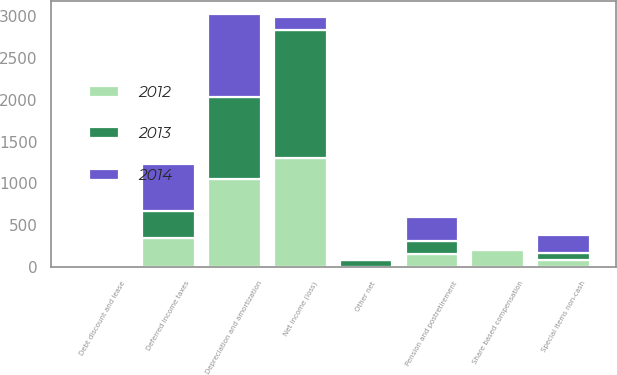Convert chart to OTSL. <chart><loc_0><loc_0><loc_500><loc_500><stacked_bar_chart><ecel><fcel>Net income (loss)<fcel>Depreciation and amortization<fcel>Debt discount and lease<fcel>Special items non-cash<fcel>Pension and postretirement<fcel>Deferred income taxes<fcel>Share based compensation<fcel>Other net<nl><fcel>2012<fcel>1310<fcel>1051<fcel>5<fcel>89<fcel>159<fcel>342<fcel>199<fcel>3<nl><fcel>2013<fcel>1526<fcel>979<fcel>4<fcel>82<fcel>154<fcel>324<fcel>24<fcel>77<nl><fcel>2014<fcel>159<fcel>999<fcel>14<fcel>214<fcel>287<fcel>569<fcel>26<fcel>13<nl></chart> 